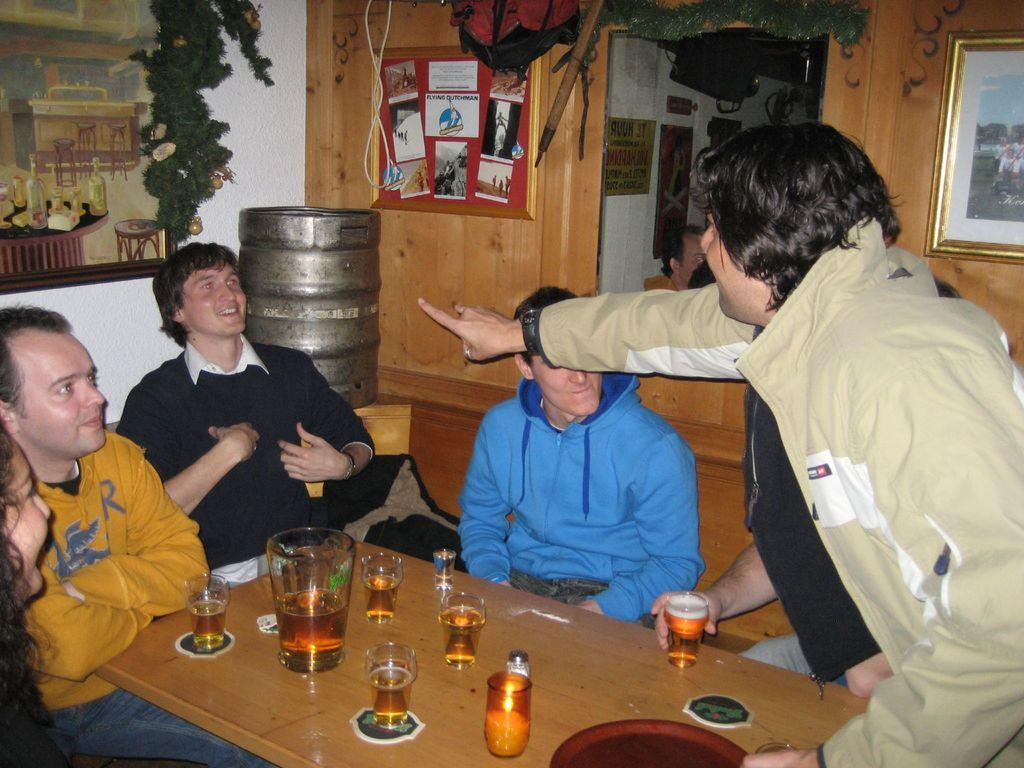What type of structure can be seen in the image? There is a wall in the image. What is hanging on the wall? There is a photo frame hanging on the wall in the image. What are the people in the image doing? The people in the image are sitting on chairs. What is present on the table in the image? There is a table in the image, and there are glasses on the table. How does the wind affect the people sitting on chairs in the image? There is no wind present in the image, so it does not affect the people sitting on chairs. 